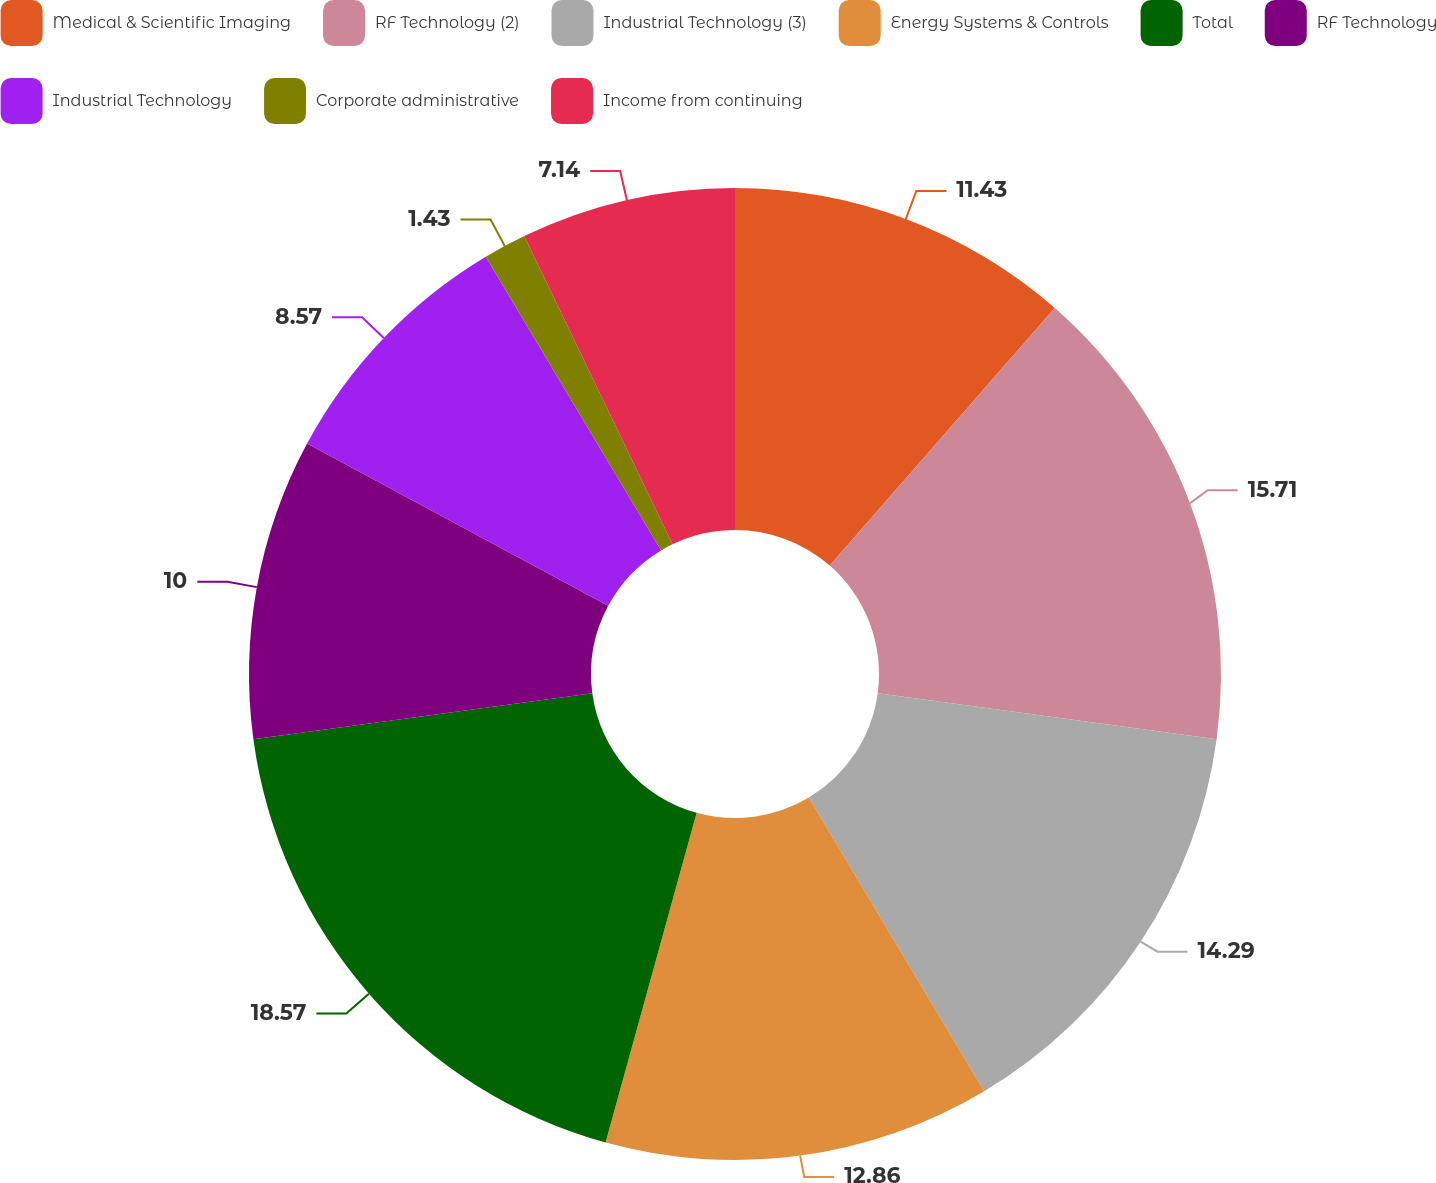Convert chart to OTSL. <chart><loc_0><loc_0><loc_500><loc_500><pie_chart><fcel>Medical & Scientific Imaging<fcel>RF Technology (2)<fcel>Industrial Technology (3)<fcel>Energy Systems & Controls<fcel>Total<fcel>RF Technology<fcel>Industrial Technology<fcel>Corporate administrative<fcel>Income from continuing<nl><fcel>11.43%<fcel>15.71%<fcel>14.29%<fcel>12.86%<fcel>18.57%<fcel>10.0%<fcel>8.57%<fcel>1.43%<fcel>7.14%<nl></chart> 